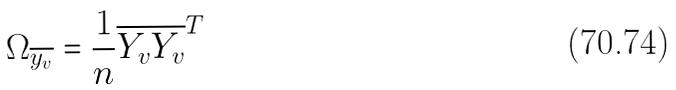Convert formula to latex. <formula><loc_0><loc_0><loc_500><loc_500>\Omega _ { \overline { y _ { v } } } = \frac { 1 } { n } \overline { Y _ { v } } \overline { Y _ { v } } ^ { T }</formula> 